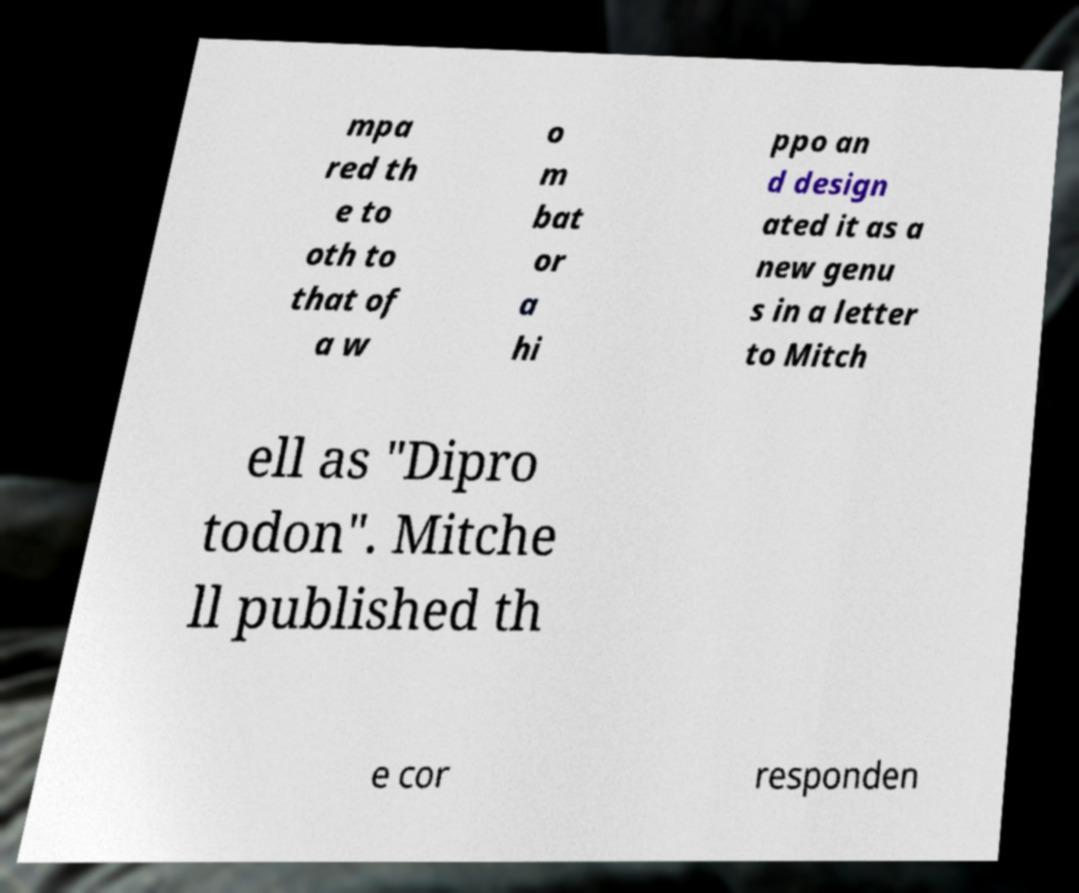Please identify and transcribe the text found in this image. mpa red th e to oth to that of a w o m bat or a hi ppo an d design ated it as a new genu s in a letter to Mitch ell as "Dipro todon". Mitche ll published th e cor responden 